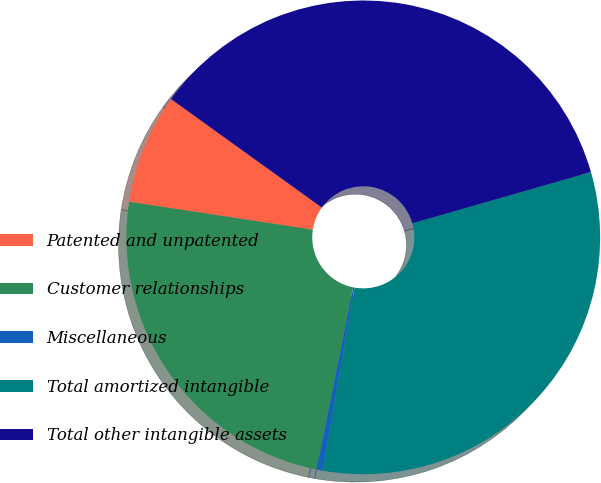Convert chart to OTSL. <chart><loc_0><loc_0><loc_500><loc_500><pie_chart><fcel>Patented and unpatented<fcel>Customer relationships<fcel>Miscellaneous<fcel>Total amortized intangible<fcel>Total other intangible assets<nl><fcel>7.53%<fcel>24.24%<fcel>0.42%<fcel>32.19%<fcel>35.63%<nl></chart> 